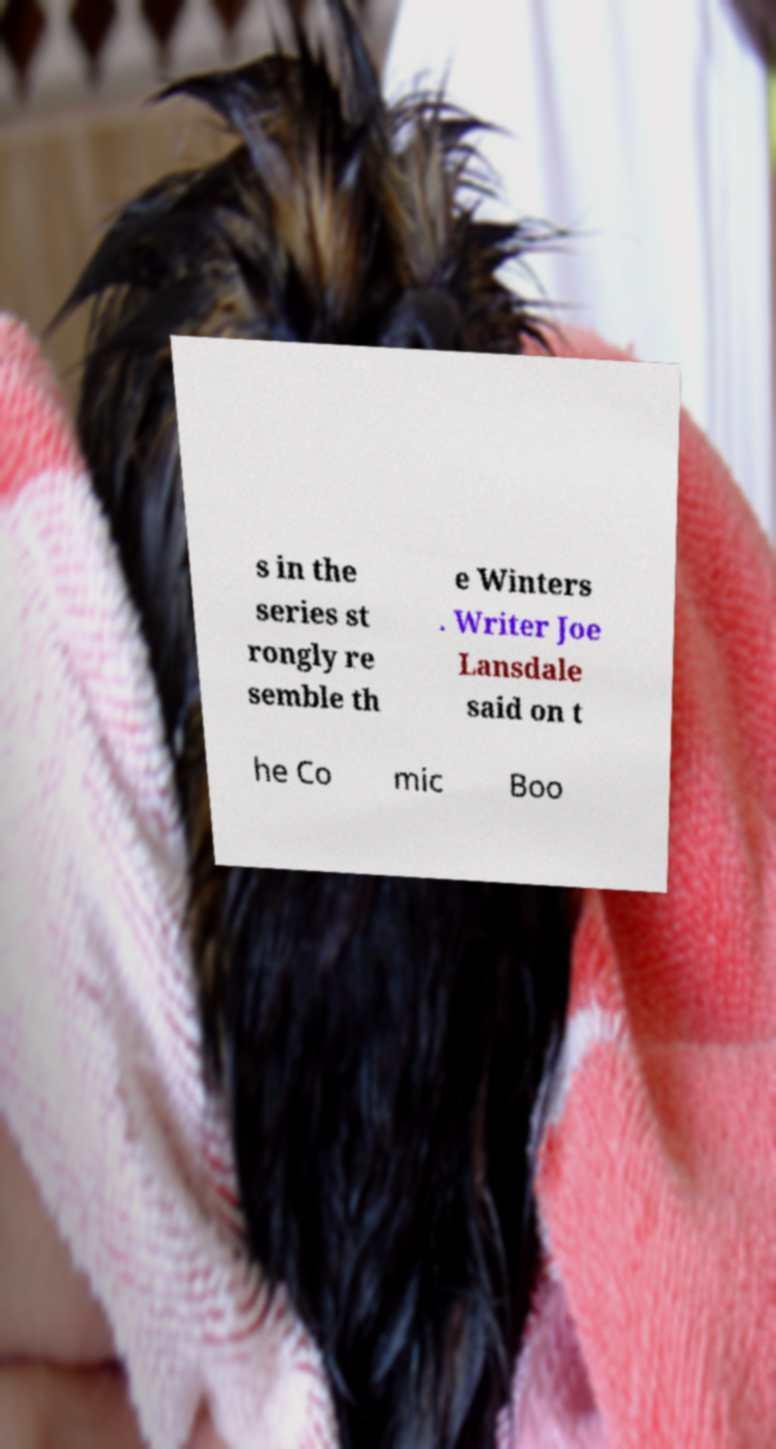Please read and relay the text visible in this image. What does it say? s in the series st rongly re semble th e Winters . Writer Joe Lansdale said on t he Co mic Boo 